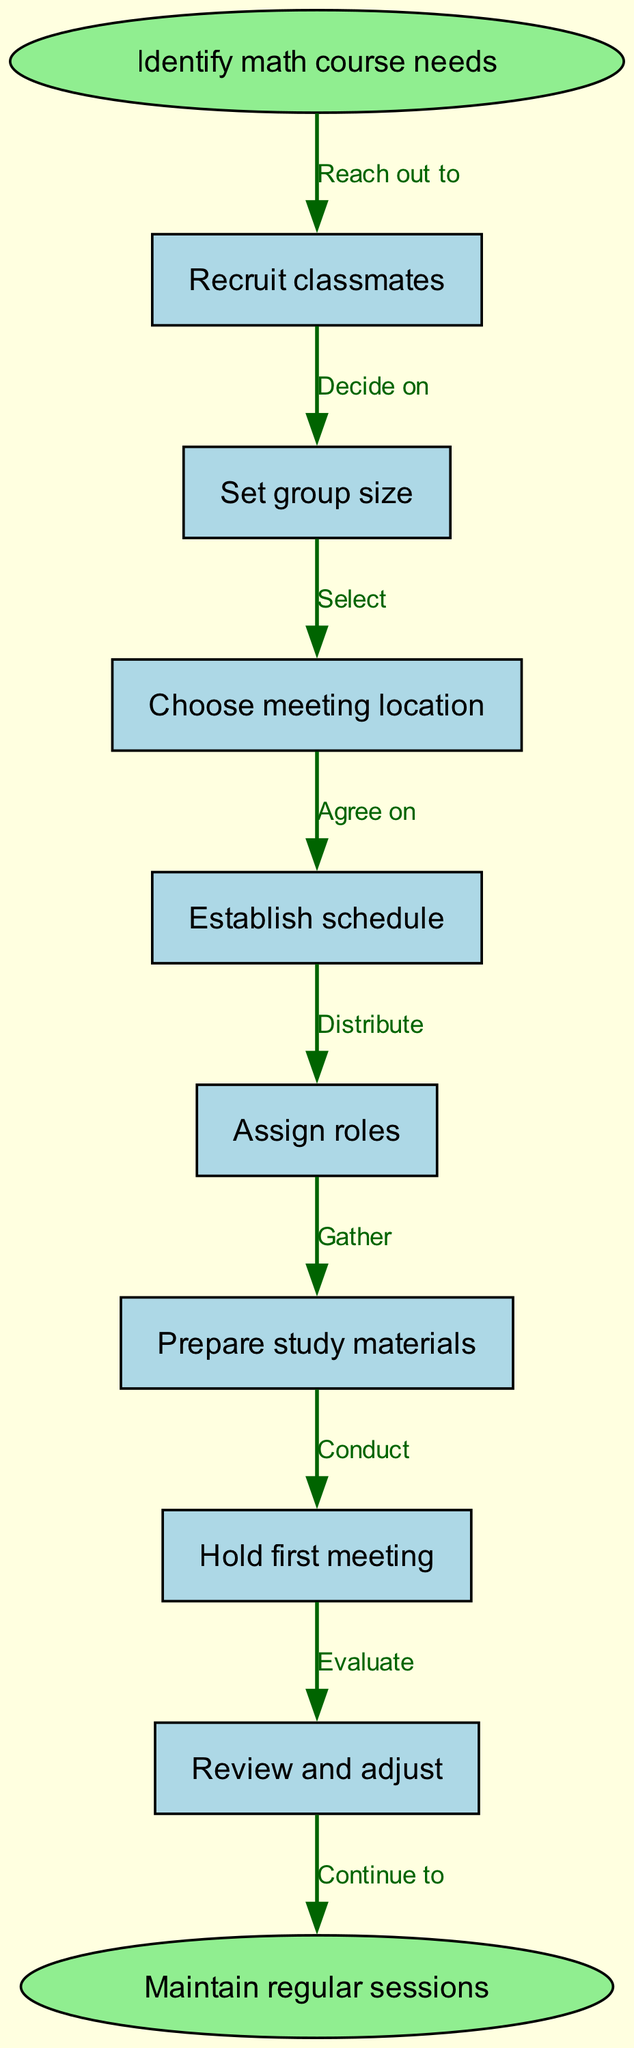What is the first step in the diagram? The first step is represented as the start node, which is "Identify math course needs". Therefore, this is the initial action to be taken in the study group process.
Answer: Identify math course needs How many steps are there in total? There are eight steps listed in the flow chart, including the start and end nodes. Each step is represented as a node, making a total of eight nodes when combined with the start and end.
Answer: Eight What is the last action to be taken? The last action happens at the end node, which is indicated as "Maintain regular sessions". This signifies the conclusion of the flow.
Answer: Maintain regular sessions What do you do after "Hold first meeting"? The next step after "Hold first meeting" is to "Review and adjust". This follows the flow directly, showing a sequential relationship between these two actions.
Answer: Review and adjust Which step involves distributing tasks? The step that involves distributing tasks is "Assign roles". This indicates the point in the flow where responsibilities within the study group are allocated among members.
Answer: Assign roles What action comes before "Prepare study materials"? The action that comes directly before "Prepare study materials" is "Assign roles". This is the logical order that leads to the gathering of materials needed for effective study sessions.
Answer: Assign roles Which node indicates the agreement on timings? The node that indicates agreeing on timings is "Establish schedule". This step is critical for setting when the study group will meet.
Answer: Establish schedule What edge connects "Recruit classmates" and "Set group size"? The edge that connects "Recruit classmates" and "Set group size" states "Decide on". This implies a decision-making process following the recruitment of group members.
Answer: Decide on What is the purpose of the "Review and adjust" step? The purpose of "Review and adjust" is to evaluate the progress and effectiveness of the study group and to make necessary changes moving forward.
Answer: Evaluate 